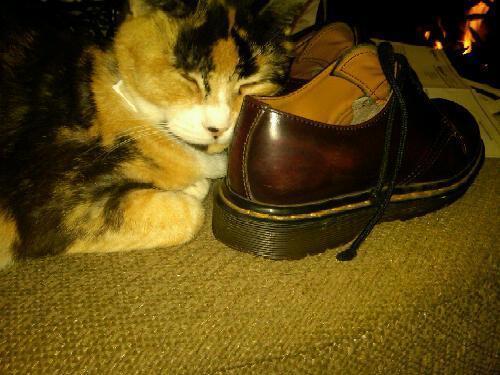How many bicycles are in the photo?
Give a very brief answer. 0. 